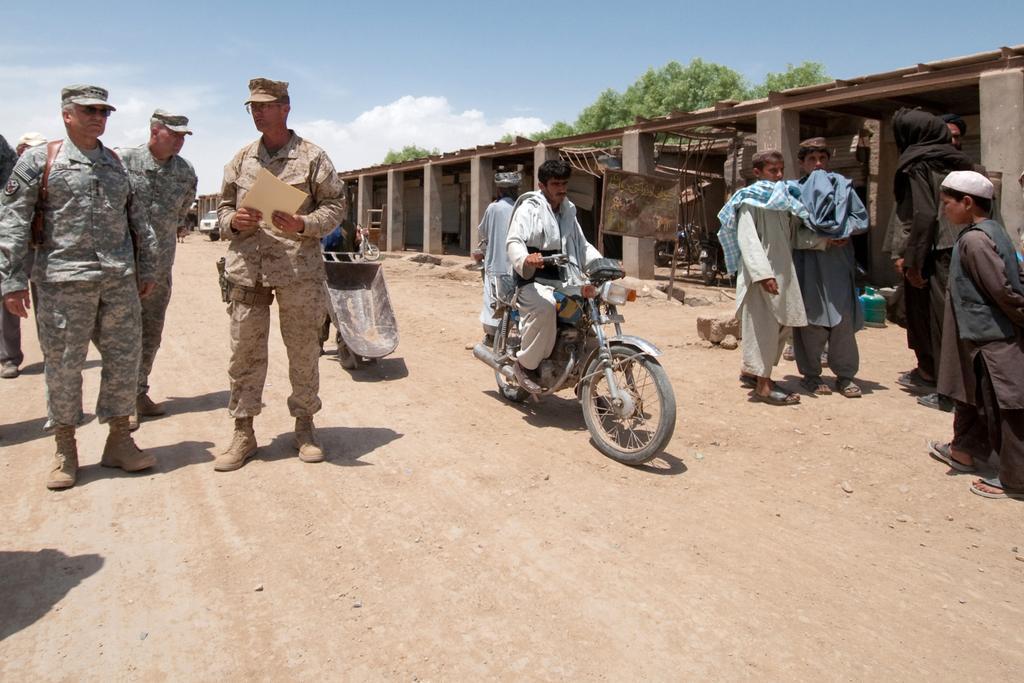Can you describe this image briefly? In this picture there are few people standing on the road. There is man riding on motor bicycle. There is a car. There is a tree. The sky is blue and cloudy. 